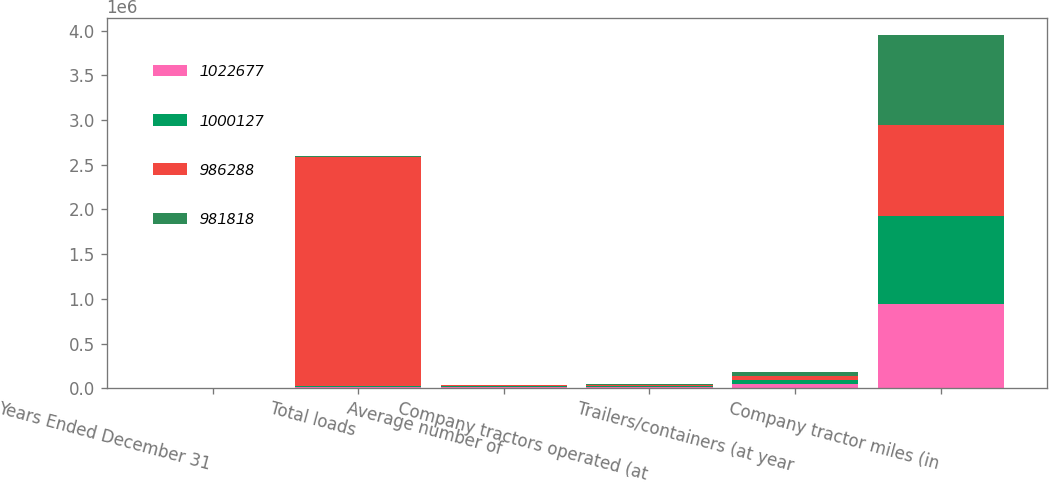Convert chart. <chart><loc_0><loc_0><loc_500><loc_500><stacked_bar_chart><ecel><fcel>Years Ended December 31<fcel>Total loads<fcel>Average number of<fcel>Company tractors operated (at<fcel>Trailers/containers (at year<fcel>Company tractor miles (in<nl><fcel>1.02268e+06<fcel>2003<fcel>10712<fcel>10293<fcel>9932<fcel>46747<fcel>943054<nl><fcel>1.00013e+06<fcel>2002<fcel>10712<fcel>10712<fcel>10653<fcel>45759<fcel>981818<nl><fcel>986288<fcel>2001<fcel>2.56592e+06<fcel>10710<fcel>10770<fcel>44318<fcel>1.02268e+06<nl><fcel>981818<fcel>2000<fcel>10712<fcel>10055<fcel>10649<fcel>44330<fcel>1.00013e+06<nl></chart> 